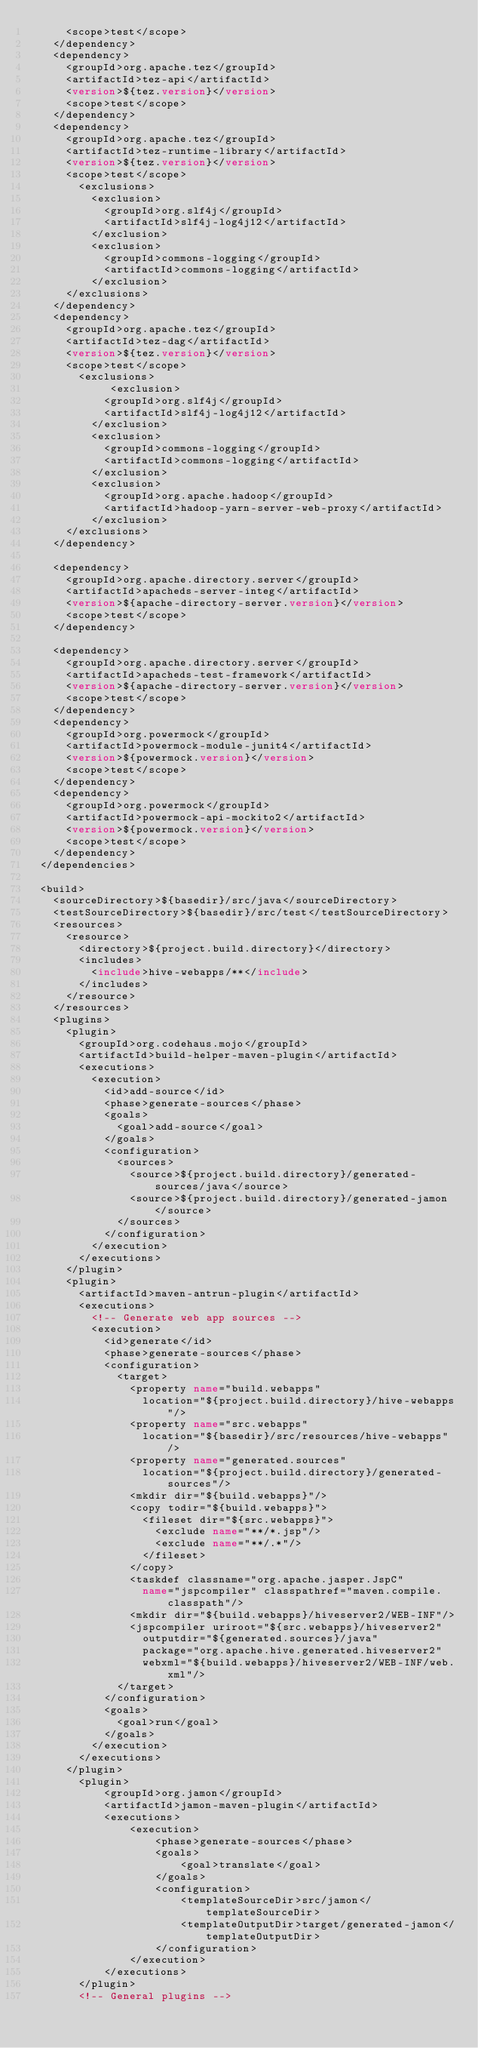<code> <loc_0><loc_0><loc_500><loc_500><_XML_>      <scope>test</scope>
    </dependency>
    <dependency>
      <groupId>org.apache.tez</groupId>
      <artifactId>tez-api</artifactId>
      <version>${tez.version}</version>
      <scope>test</scope>
    </dependency>
    <dependency>
      <groupId>org.apache.tez</groupId>
      <artifactId>tez-runtime-library</artifactId>
      <version>${tez.version}</version>
      <scope>test</scope>
        <exclusions>
          <exclusion>
            <groupId>org.slf4j</groupId>
            <artifactId>slf4j-log4j12</artifactId>
          </exclusion>
          <exclusion>
            <groupId>commons-logging</groupId>
            <artifactId>commons-logging</artifactId>
          </exclusion>
      </exclusions>
    </dependency>
    <dependency>
      <groupId>org.apache.tez</groupId>
      <artifactId>tez-dag</artifactId>
      <version>${tez.version}</version>
      <scope>test</scope>
        <exclusions>
             <exclusion>
            <groupId>org.slf4j</groupId>
            <artifactId>slf4j-log4j12</artifactId>
          </exclusion>
          <exclusion>
            <groupId>commons-logging</groupId>
            <artifactId>commons-logging</artifactId>
          </exclusion>
          <exclusion>
            <groupId>org.apache.hadoop</groupId>
            <artifactId>hadoop-yarn-server-web-proxy</artifactId>
          </exclusion>
      </exclusions>
    </dependency>

    <dependency>
      <groupId>org.apache.directory.server</groupId>
      <artifactId>apacheds-server-integ</artifactId>
      <version>${apache-directory-server.version}</version>
      <scope>test</scope>
    </dependency>

    <dependency>
      <groupId>org.apache.directory.server</groupId>
      <artifactId>apacheds-test-framework</artifactId>
      <version>${apache-directory-server.version}</version>
      <scope>test</scope>
    </dependency>
    <dependency>
      <groupId>org.powermock</groupId>
      <artifactId>powermock-module-junit4</artifactId>
      <version>${powermock.version}</version>
      <scope>test</scope>
    </dependency>
    <dependency>
      <groupId>org.powermock</groupId>
      <artifactId>powermock-api-mockito2</artifactId>
      <version>${powermock.version}</version>
      <scope>test</scope>
    </dependency>
  </dependencies>

  <build>
    <sourceDirectory>${basedir}/src/java</sourceDirectory>
    <testSourceDirectory>${basedir}/src/test</testSourceDirectory>
    <resources>
      <resource>
        <directory>${project.build.directory}</directory>
        <includes>
          <include>hive-webapps/**</include>
        </includes>
      </resource>
    </resources>
    <plugins>
      <plugin>
        <groupId>org.codehaus.mojo</groupId>
        <artifactId>build-helper-maven-plugin</artifactId>
        <executions>
          <execution>
            <id>add-source</id>
            <phase>generate-sources</phase>
            <goals>
              <goal>add-source</goal>
            </goals>
            <configuration>
              <sources>
                <source>${project.build.directory}/generated-sources/java</source>
                <source>${project.build.directory}/generated-jamon</source>
              </sources>
            </configuration>
          </execution>
        </executions>
      </plugin>
      <plugin>
        <artifactId>maven-antrun-plugin</artifactId>
        <executions>
          <!-- Generate web app sources -->
          <execution>
            <id>generate</id>
            <phase>generate-sources</phase>
            <configuration>
              <target>
                <property name="build.webapps"
                  location="${project.build.directory}/hive-webapps"/>
                <property name="src.webapps"
                  location="${basedir}/src/resources/hive-webapps"/>
                <property name="generated.sources"
                  location="${project.build.directory}/generated-sources"/>
                <mkdir dir="${build.webapps}"/>
                <copy todir="${build.webapps}">
                  <fileset dir="${src.webapps}">
                    <exclude name="**/*.jsp"/>
                    <exclude name="**/.*"/>
                  </fileset>
                </copy>
                <taskdef classname="org.apache.jasper.JspC"
                  name="jspcompiler" classpathref="maven.compile.classpath"/>
                <mkdir dir="${build.webapps}/hiveserver2/WEB-INF"/>
                <jspcompiler uriroot="${src.webapps}/hiveserver2"
                  outputdir="${generated.sources}/java"
                  package="org.apache.hive.generated.hiveserver2"
                  webxml="${build.webapps}/hiveserver2/WEB-INF/web.xml"/>
              </target>
            </configuration>
            <goals>
              <goal>run</goal>
            </goals>
          </execution>
        </executions>
      </plugin>
        <plugin>
            <groupId>org.jamon</groupId>
            <artifactId>jamon-maven-plugin</artifactId>
            <executions>
                <execution>
                    <phase>generate-sources</phase>
                    <goals>
                        <goal>translate</goal>
                    </goals>
                    <configuration>
                        <templateSourceDir>src/jamon</templateSourceDir>
                        <templateOutputDir>target/generated-jamon</templateOutputDir>
                    </configuration>
                </execution>
            </executions>
        </plugin>
        <!-- General plugins --></code> 